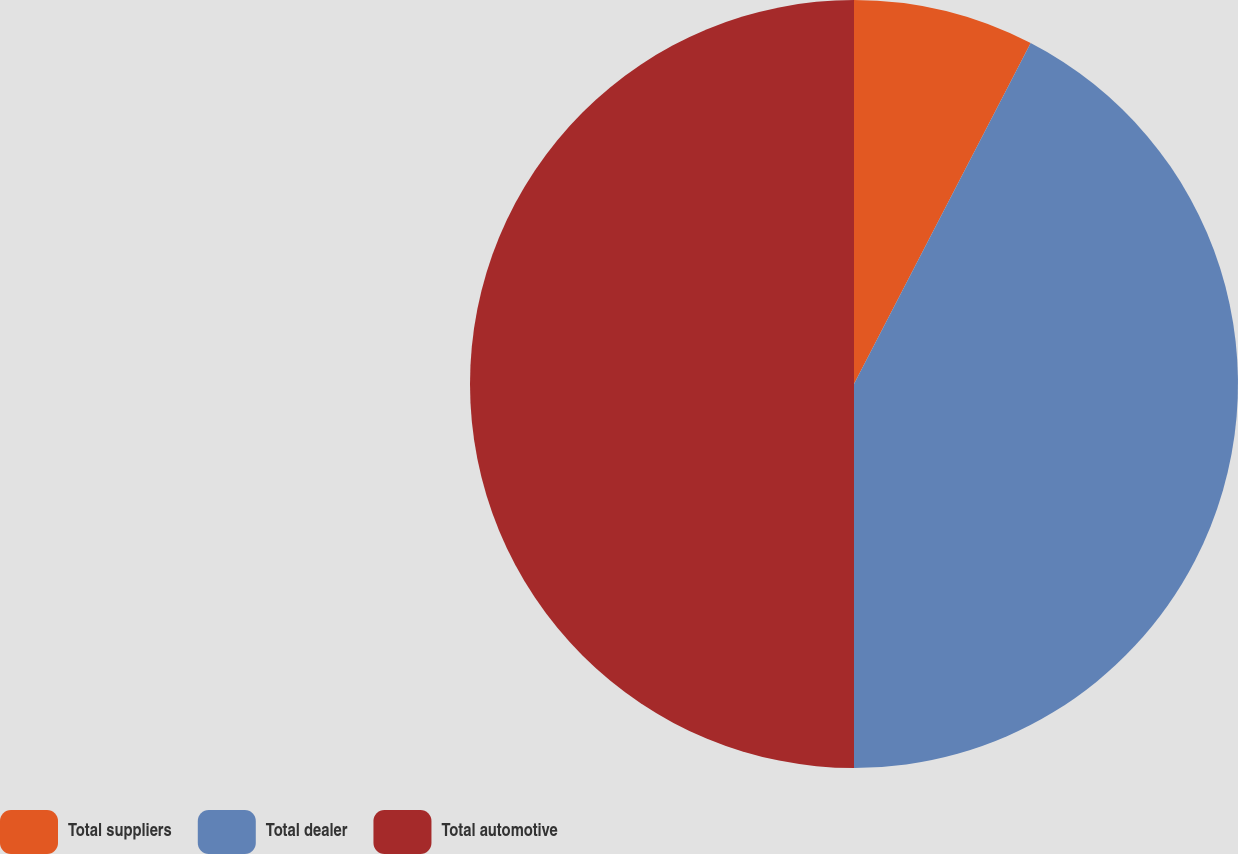Convert chart to OTSL. <chart><loc_0><loc_0><loc_500><loc_500><pie_chart><fcel>Total suppliers<fcel>Total dealer<fcel>Total automotive<nl><fcel>7.61%<fcel>42.39%<fcel>50.0%<nl></chart> 